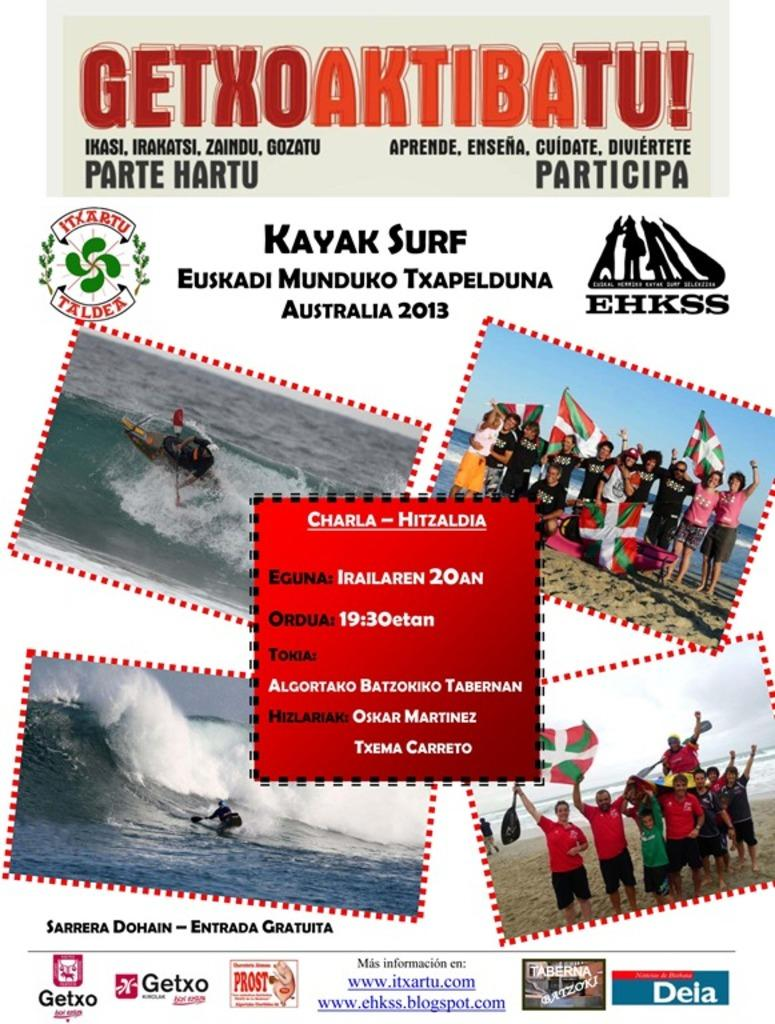What is present in the image that contains both images and text? There is a poster in the image that contains images and text. How many sheep are depicted in the poster? There are no sheep present in the poster or the image. 